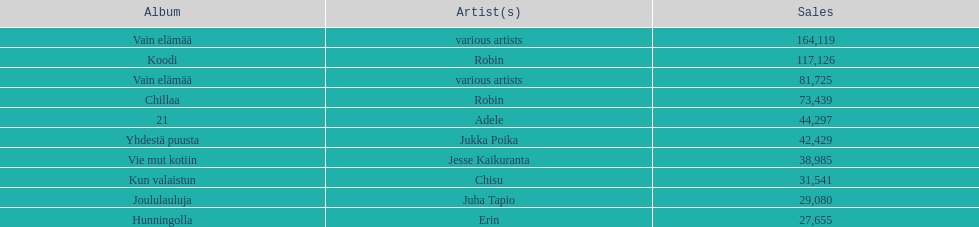Which album had the smallest number of sales? Hunningolla. 